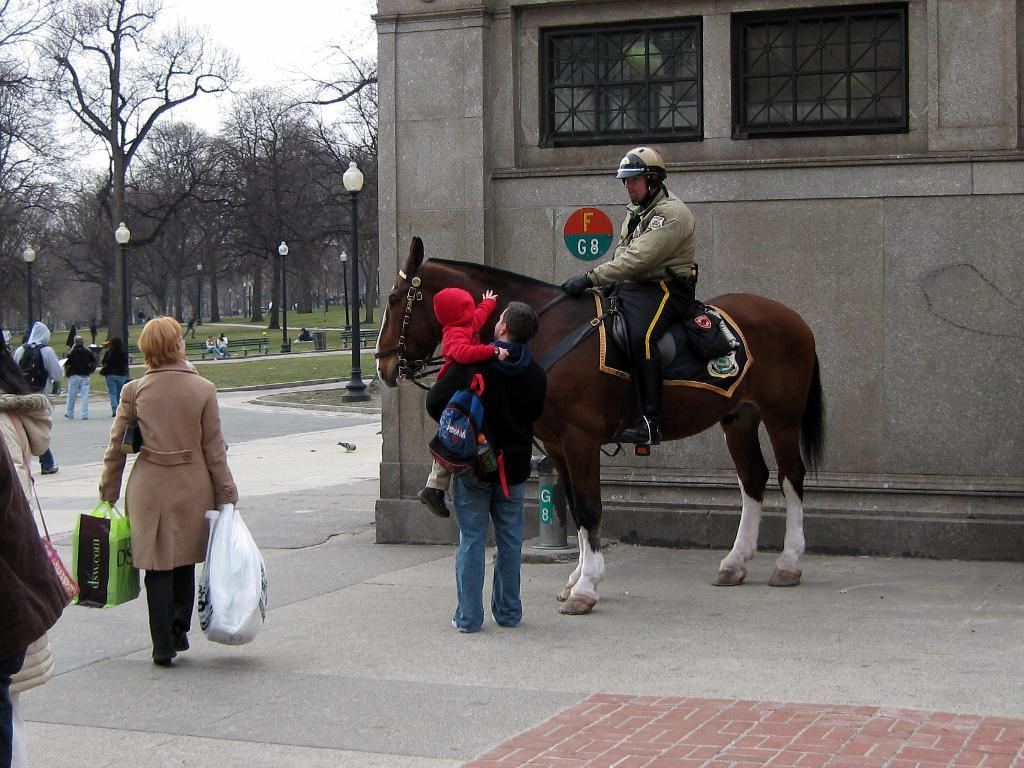How many people are in the image? There is a group of persons in the image. What is the jockey doing in the image? The jockey is riding a horse in the image. What can be seen on the left side of the image? There are trees on the left side of the image. What type of ink is being used to write on the horse's saddle in the image? There is no ink or writing present on the horse's saddle in the image. What is the jockey eating for breakfast in the image? There is no breakfast or eating activity depicted in the image. 